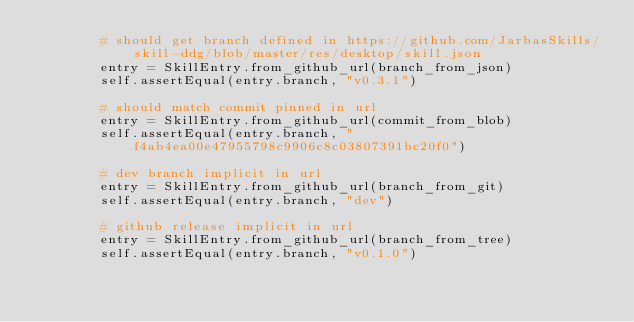<code> <loc_0><loc_0><loc_500><loc_500><_Python_>        # should get branch defined in https://github.com/JarbasSkills/skill-ddg/blob/master/res/desktop/skill.json
        entry = SkillEntry.from_github_url(branch_from_json)
        self.assertEqual(entry.branch, "v0.3.1")

        # should match commit pinned in url
        entry = SkillEntry.from_github_url(commit_from_blob)
        self.assertEqual(entry.branch, "f4ab4ea00e47955798c9906c8c03807391bc20f0")

        # dev branch implicit in url
        entry = SkillEntry.from_github_url(branch_from_git)
        self.assertEqual(entry.branch, "dev")

        # github release implicit in url
        entry = SkillEntry.from_github_url(branch_from_tree)
        self.assertEqual(entry.branch, "v0.1.0")

</code> 